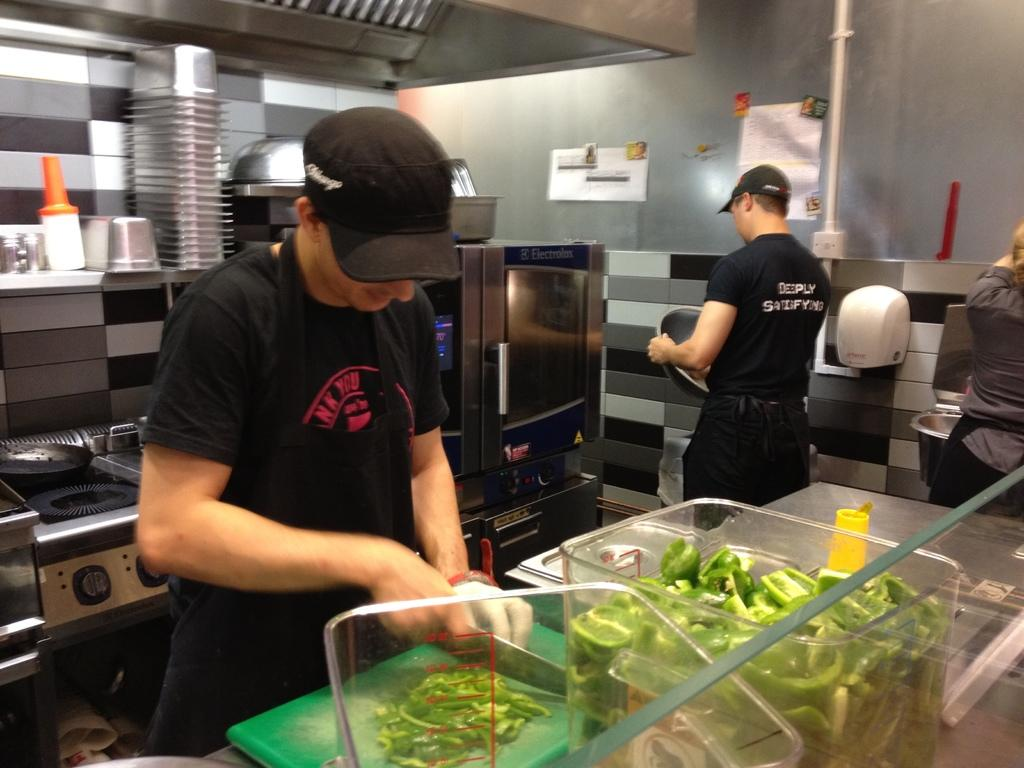<image>
Summarize the visual content of the image. A man wearing a black shirt that says deeply satisfying on the back prepares to retrieve food from the microwave. 